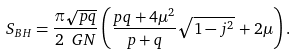Convert formula to latex. <formula><loc_0><loc_0><loc_500><loc_500>S _ { B H } = \frac { \pi \sqrt { p q } } { 2 \ G N } \left ( \frac { p q + 4 \mu ^ { 2 } } { p + q } \sqrt { 1 - j ^ { 2 } } \, + 2 \mu \right ) .</formula> 